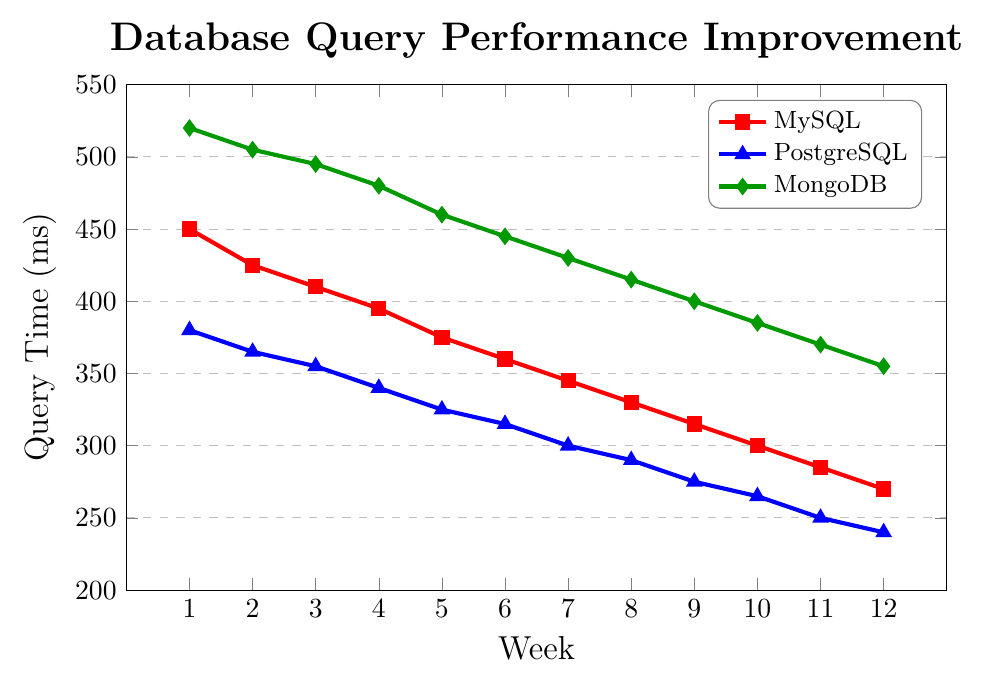What's the average query time for MySQL over the 12 weeks? To find the average, sum all the MySQL query times over the 12 weeks (450 + 425 + 410 + 395 + 375 + 360 + 345 + 330 + 315 + 300 + 285 + 270) = 4260. Then divide by 12, which gives 4260 / 12 = 355 ms
Answer: 355 ms Which database had the highest initial query time in Week 1? In Week 1, the query times are MySQL: 450 ms, PostgreSQL: 380 ms, and MongoDB: 520 ms. The highest value among them is 520 ms for MongoDB
Answer: MongoDB Which week saw the smallest decrease in PostgreSQL query time compared to the previous week? To find the smallest decrease, compare the differences week over week: (380 - 365) = 15, (365 - 355) = 10, (355 - 340) = 15, (340 - 325) = 15, (325 - 315) = 10, (315 - 300) = 15, (300 - 290) = 10, (290 - 275) = 15, (275 - 265) = 10, (265 - 250) = 15, (250 - 240) = 10. The smallest differences are 10 ms, occurring in Weeks 3, 5, 7, 9, 11
Answer: Week 3, Week 5, Week 7, Week 9, Week 11 By how much did the MongoDB query time improve over 12 weeks? Subtract the query time at Week 12 from Week 1: 520 ms - 355 ms = 165 ms
Answer: 165 ms How does the query time of MySQL in Week 6 compare to PostgreSQL in Week 3? The MySQL query time in Week 6 is 360 ms. The PostgreSQL query time in Week 3 is 355 ms. Since 360 ms > 355 ms
Answer: MySQL in Week 6 is greater Which database showed the most significant improvement in query time by Week 12? MySQL: 450 - 270 = 180 ms, PostgreSQL: 380 - 240 = 140 ms, MongoDB: 520 - 355 = 165 ms. The most significant improvement is 180 ms for MySQL
Answer: MySQL What is the total reduction in query time for PostgreSQL from Week 1 to Week 12? Subtract the query time at Week 12 from Week 1: 380 ms - 240 ms = 140 ms
Answer: 140 ms If we average the query times in Week 6 across all databases, what is the result? Sum the query times in Week 6 (360 + 315 + 445) = 1120, then divide by 3: 1120 / 3 ≈ 373.33 ms
Answer: 373.33 ms 